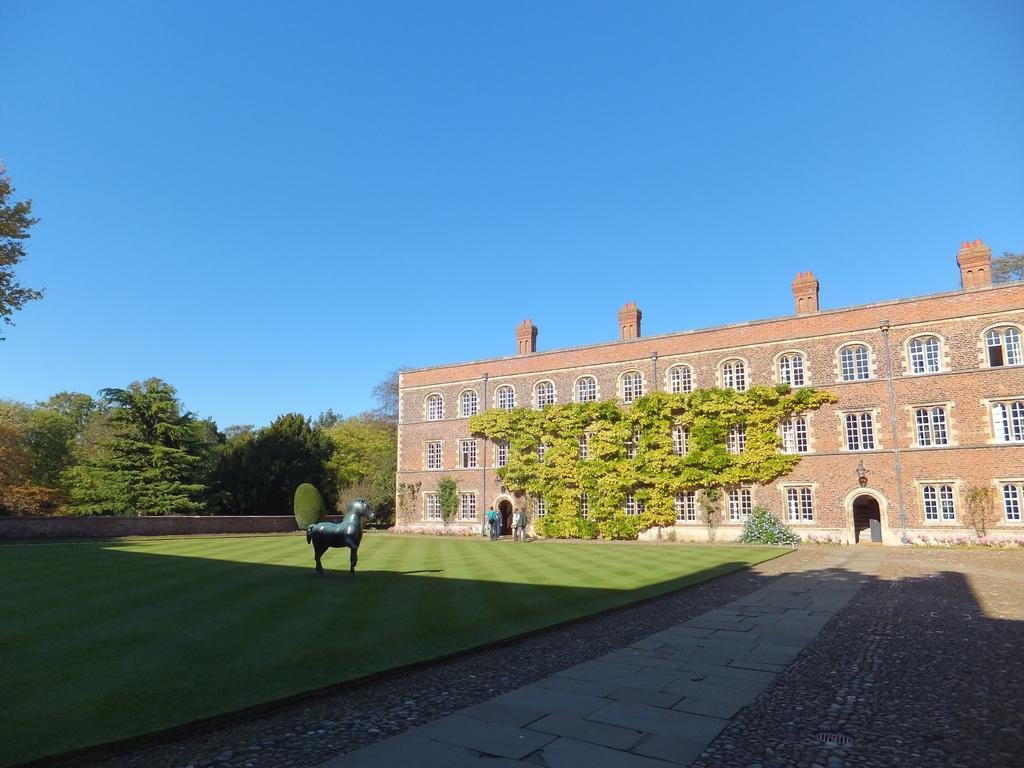What type of structure is present in the image? There is a building in the image. What feature can be seen on the building? The building has windows. What type of vegetation is visible in the image? There are trees in the image. What color is the sky in the image? The sky is blue in the image. What type of object is present in the image that represents an animal? There is an animal statue in the image. What type of ground surface is visible in the image? There is grass visible in the image. What type of paper can be seen blowing in the wind in the image? There is no paper visible in the image; it only features a building, trees, a blue sky, an animal statue, and grass. 